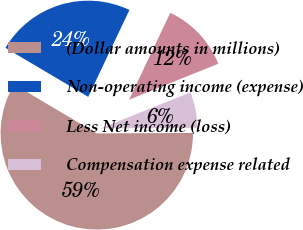<chart> <loc_0><loc_0><loc_500><loc_500><pie_chart><fcel>(Dollar amounts in millions)<fcel>Non-operating income (expense)<fcel>Less Net income (loss)<fcel>Compensation expense related<nl><fcel>58.59%<fcel>23.54%<fcel>11.86%<fcel>6.02%<nl></chart> 